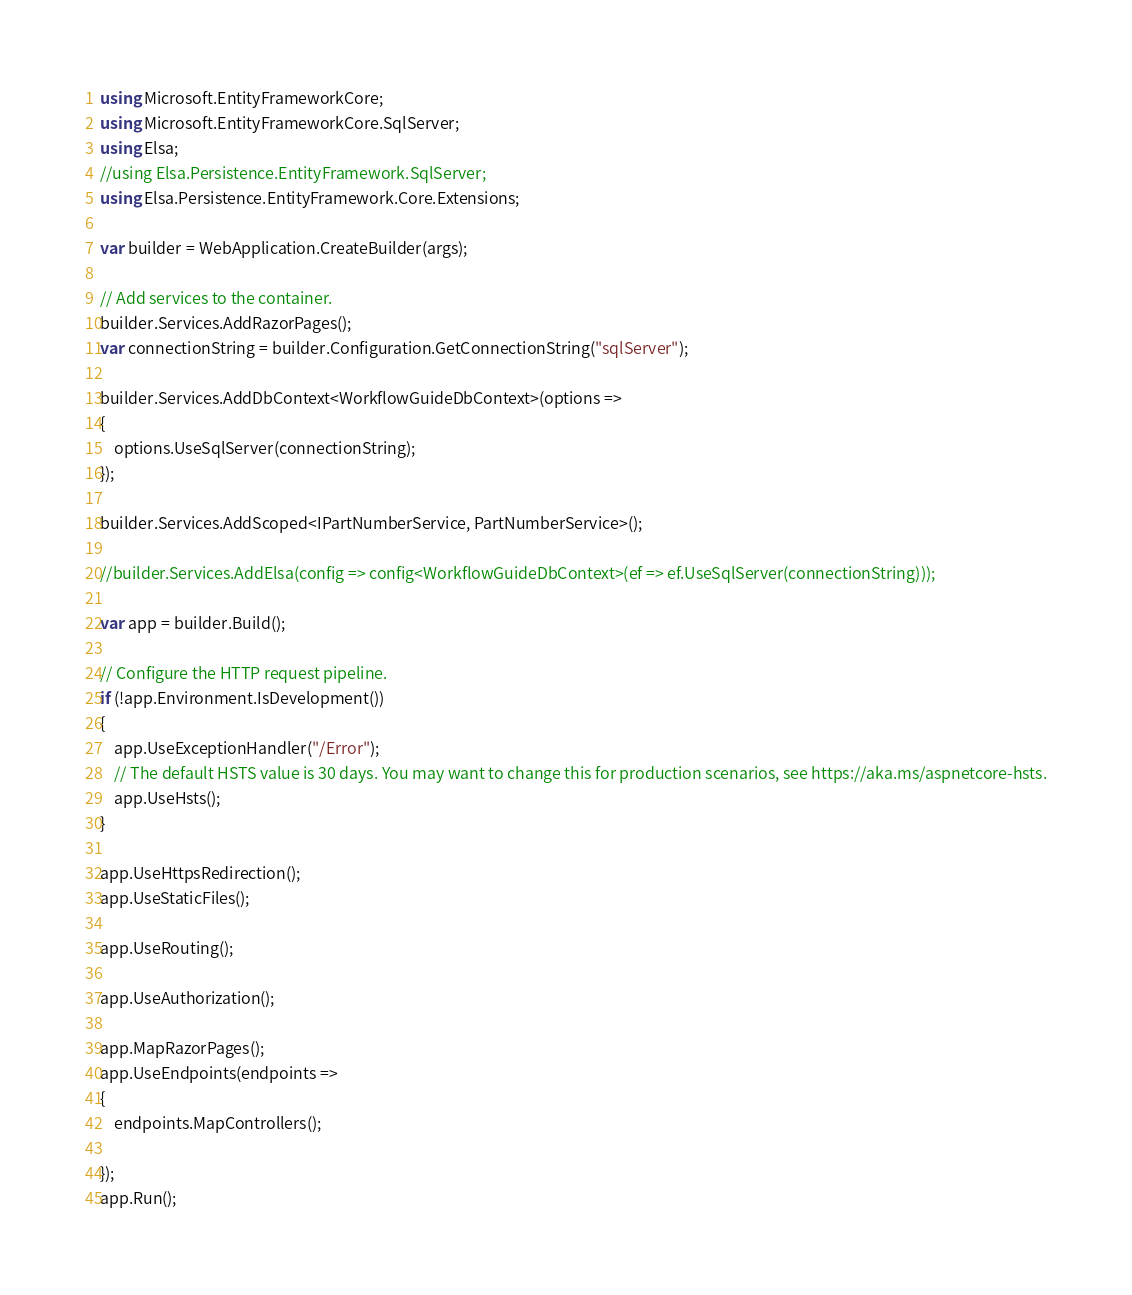<code> <loc_0><loc_0><loc_500><loc_500><_C#_>using Microsoft.EntityFrameworkCore;
using Microsoft.EntityFrameworkCore.SqlServer;
using Elsa;
//using Elsa.Persistence.EntityFramework.SqlServer;
using Elsa.Persistence.EntityFramework.Core.Extensions;

var builder = WebApplication.CreateBuilder(args);

// Add services to the container.
builder.Services.AddRazorPages();
var connectionString = builder.Configuration.GetConnectionString("sqlServer");

builder.Services.AddDbContext<WorkflowGuideDbContext>(options =>
{
    options.UseSqlServer(connectionString);
});

builder.Services.AddScoped<IPartNumberService, PartNumberService>();

//builder.Services.AddElsa(config => config<WorkflowGuideDbContext>(ef => ef.UseSqlServer(connectionString)));

var app = builder.Build();

// Configure the HTTP request pipeline.
if (!app.Environment.IsDevelopment())
{
    app.UseExceptionHandler("/Error");
    // The default HSTS value is 30 days. You may want to change this for production scenarios, see https://aka.ms/aspnetcore-hsts.
    app.UseHsts();
}

app.UseHttpsRedirection();
app.UseStaticFiles();

app.UseRouting();

app.UseAuthorization();

app.MapRazorPages();
app.UseEndpoints(endpoints =>
{
    endpoints.MapControllers();

});
app.Run();
</code> 